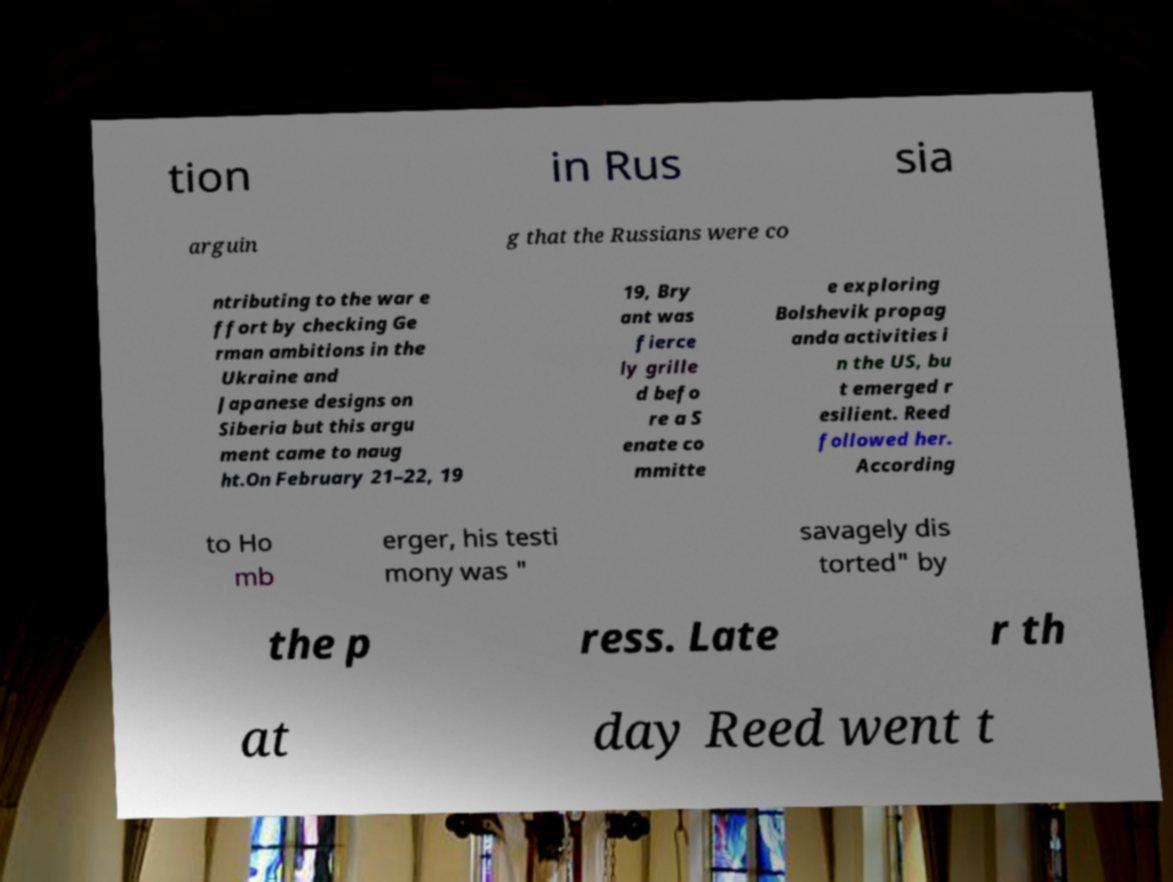There's text embedded in this image that I need extracted. Can you transcribe it verbatim? tion in Rus sia arguin g that the Russians were co ntributing to the war e ffort by checking Ge rman ambitions in the Ukraine and Japanese designs on Siberia but this argu ment came to naug ht.On February 21–22, 19 19, Bry ant was fierce ly grille d befo re a S enate co mmitte e exploring Bolshevik propag anda activities i n the US, bu t emerged r esilient. Reed followed her. According to Ho mb erger, his testi mony was " savagely dis torted" by the p ress. Late r th at day Reed went t 